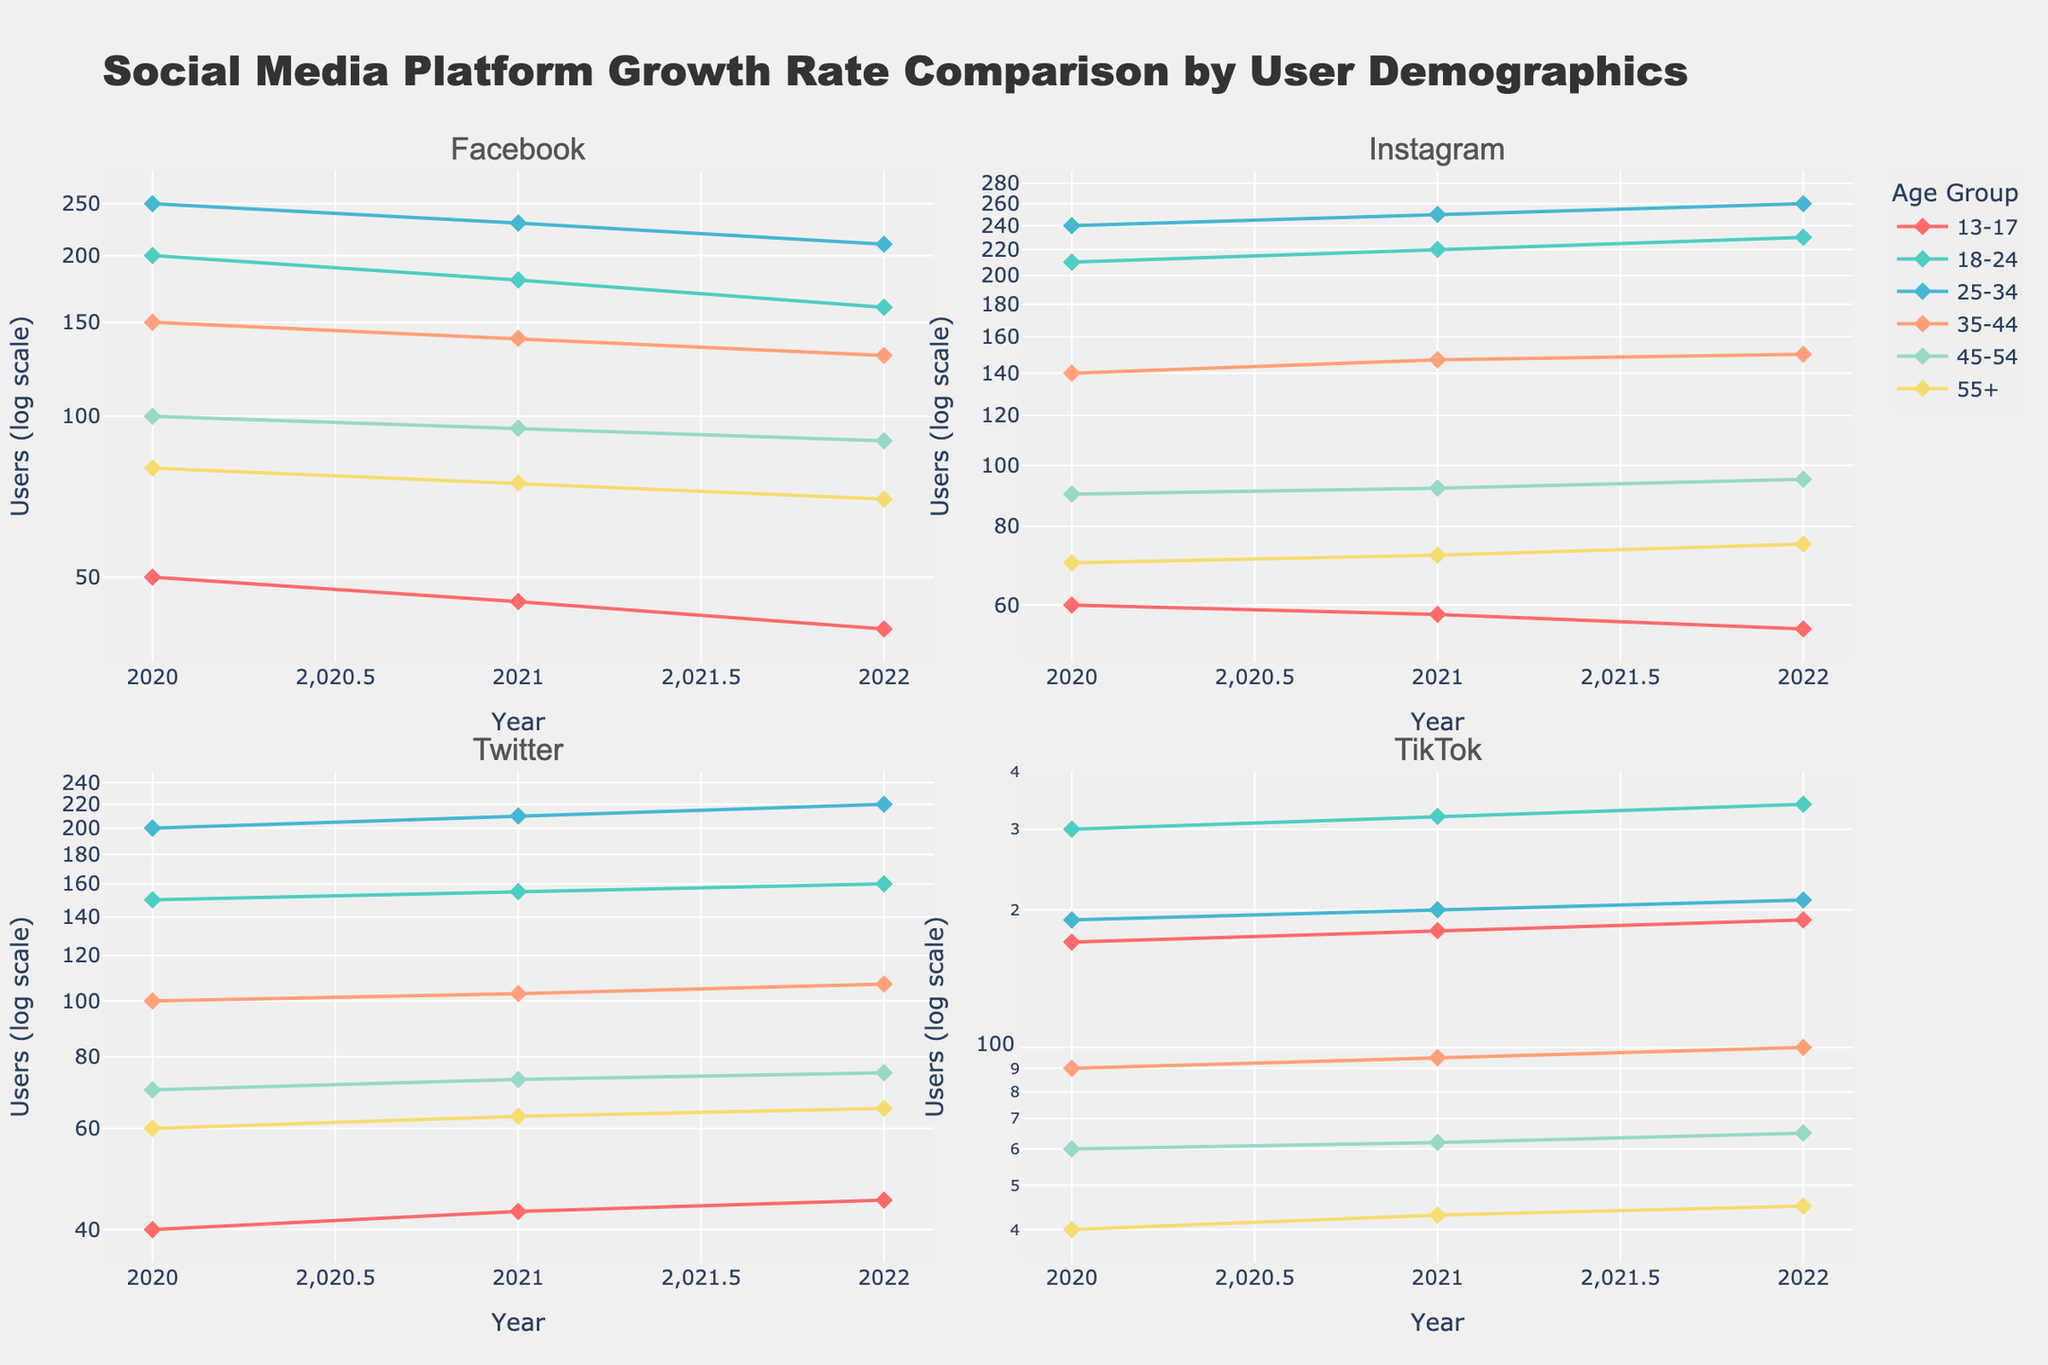What's the title of the figure? The title is typically displayed at the top of the figure to describe the overall content. Look at the top-center of the figure for this information.
Answer: Social Media Platform Growth Rate Comparison by User Demographics How many subplots are there in the figure? Subplots are individual plots within a larger figure. Scan the entire figure to count the number of distinct plots.
Answer: 4 Which platform has the most users in the age group 18-24 in the year 2022? To answer this, find the subplot for each platform and identify the data series for the 18-24 age group, then look for the year 2022 and compare the values.
Answer: TikTok What is the range of user counts for Twitter in the age group 25-34 from 2020 to 2022? Locate the subplot for Twitter and the data series for the 25-34 age group. Read the user counts for the years 2020, 2021, and 2022 to determine the range (highest value minus lowest value).
Answer: 20 (220-200) Which platform shows a decreasing trend in user count in the 13-17 age group? Identify the subplots for each platform and examine the data series for the 13-17 age group. Look for a decreasing trend over the years.
Answer: Facebook How does the user count change for 55+ age group users on Instagram from 2020 to 2022? Find the subplot for Instagram and look at the data series for the 55+ age group. Assess the user counts for the years 2020, 2021, and 2022.
Answer: Increases from 70 to 75 Which age group has a steady increase in user counts on Twitter over the years 2020 to 2022? In the Twitter subplot, examine the data series for each age group. Look for the series that shows a steady increase from 2020 to 2022.
Answer: 13-17 Compare the growth rate of users in the age group 25-34 for Facebook and TikTok from 2020 to 2022. Examine the subplots of Facebook and TikTok, specifically the data series for the 25-34 age group. Calculate the percentage growth rate for each platform [(2022 count - 2020 count) / 2020 count * 100%].
Answer: Facebook: -16%, TikTok: 10.5% Which platform has the lowest number of users in any given age group and year? Scan all the subplots for the minimum user count by inspecting each age group's data across all years and platforms.
Answer: Twitter, 13-17, 2020 (40) 